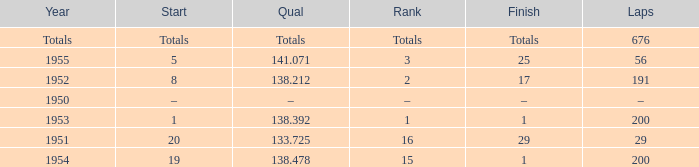How many laps does the one ranked 16 have? 29.0. 